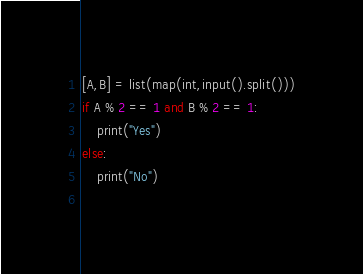<code> <loc_0><loc_0><loc_500><loc_500><_Python_>[A,B] = list(map(int,input().split()))
if A % 2 == 1 and B % 2 == 1:
    print("Yes")
else:
    print("No")
    </code> 